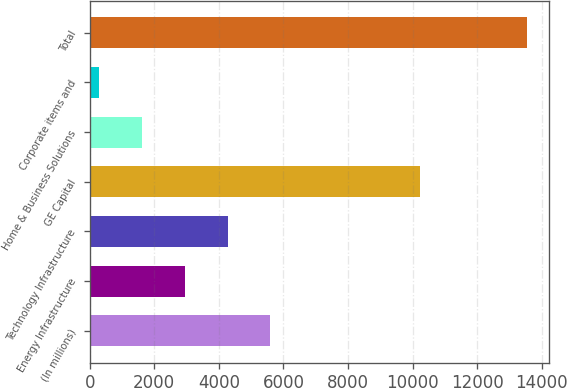<chart> <loc_0><loc_0><loc_500><loc_500><bar_chart><fcel>(In millions)<fcel>Energy Infrastructure<fcel>Technology Infrastructure<fcel>GE Capital<fcel>Home & Business Solutions<fcel>Corporate items and<fcel>Total<nl><fcel>5594.2<fcel>2946.6<fcel>4270.4<fcel>10226<fcel>1622.8<fcel>299<fcel>13537<nl></chart> 